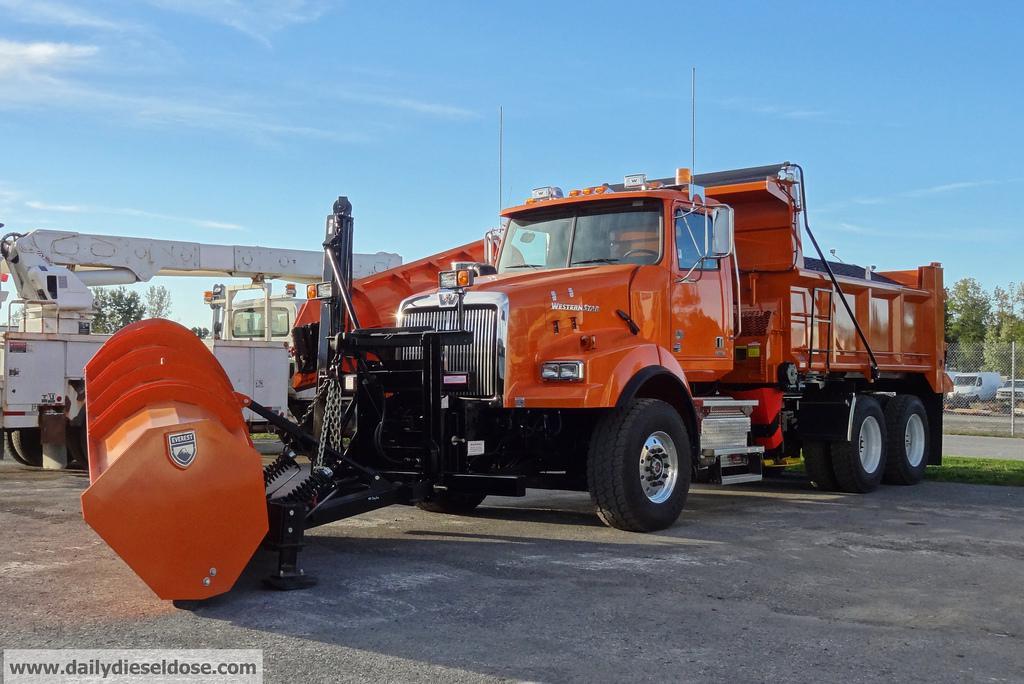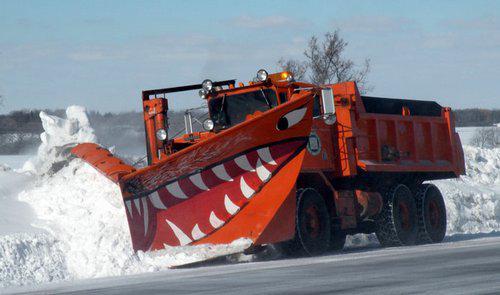The first image is the image on the left, the second image is the image on the right. Considering the images on both sides, is "An image includes a truck with an orange plow and a white cab." valid? Answer yes or no. No. The first image is the image on the left, the second image is the image on the right. Examine the images to the left and right. Is the description "There is one snow plow in the image on the right." accurate? Answer yes or no. Yes. 